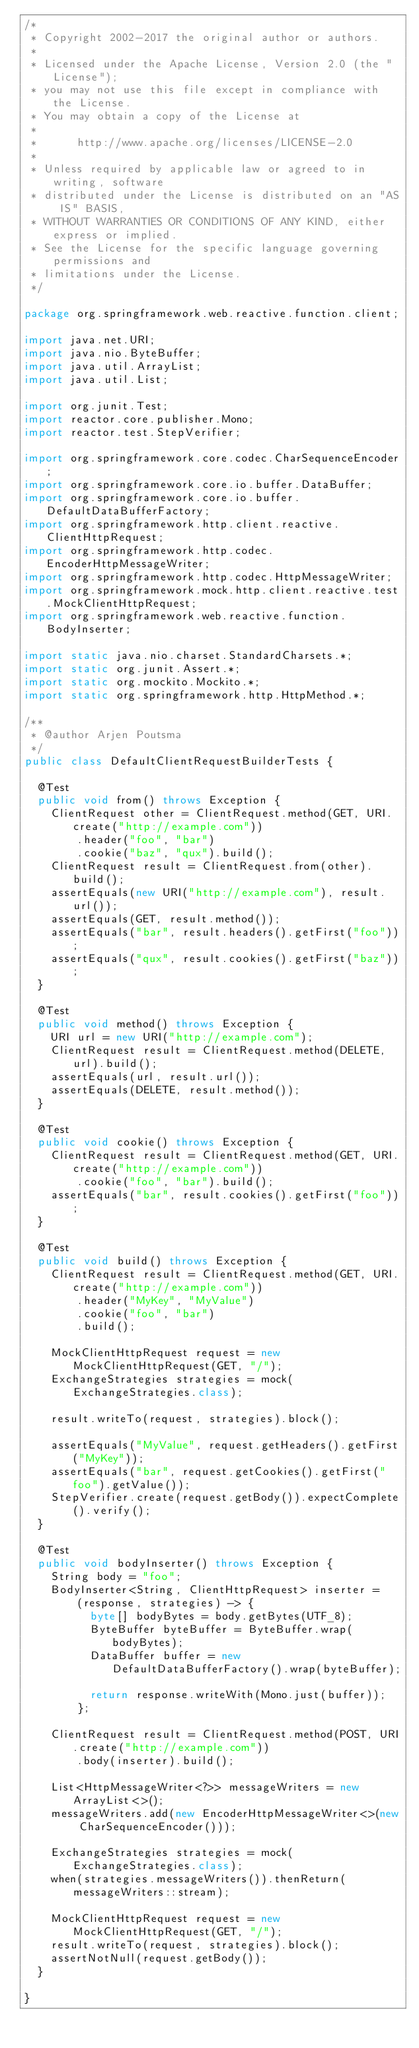<code> <loc_0><loc_0><loc_500><loc_500><_Java_>/*
 * Copyright 2002-2017 the original author or authors.
 *
 * Licensed under the Apache License, Version 2.0 (the "License");
 * you may not use this file except in compliance with the License.
 * You may obtain a copy of the License at
 *
 *      http://www.apache.org/licenses/LICENSE-2.0
 *
 * Unless required by applicable law or agreed to in writing, software
 * distributed under the License is distributed on an "AS IS" BASIS,
 * WITHOUT WARRANTIES OR CONDITIONS OF ANY KIND, either express or implied.
 * See the License for the specific language governing permissions and
 * limitations under the License.
 */

package org.springframework.web.reactive.function.client;

import java.net.URI;
import java.nio.ByteBuffer;
import java.util.ArrayList;
import java.util.List;

import org.junit.Test;
import reactor.core.publisher.Mono;
import reactor.test.StepVerifier;

import org.springframework.core.codec.CharSequenceEncoder;
import org.springframework.core.io.buffer.DataBuffer;
import org.springframework.core.io.buffer.DefaultDataBufferFactory;
import org.springframework.http.client.reactive.ClientHttpRequest;
import org.springframework.http.codec.EncoderHttpMessageWriter;
import org.springframework.http.codec.HttpMessageWriter;
import org.springframework.mock.http.client.reactive.test.MockClientHttpRequest;
import org.springframework.web.reactive.function.BodyInserter;

import static java.nio.charset.StandardCharsets.*;
import static org.junit.Assert.*;
import static org.mockito.Mockito.*;
import static org.springframework.http.HttpMethod.*;

/**
 * @author Arjen Poutsma
 */
public class DefaultClientRequestBuilderTests {

	@Test
	public void from() throws Exception {
		ClientRequest other = ClientRequest.method(GET, URI.create("http://example.com"))
				.header("foo", "bar")
				.cookie("baz", "qux").build();
		ClientRequest result = ClientRequest.from(other).build();
		assertEquals(new URI("http://example.com"), result.url());
		assertEquals(GET, result.method());
		assertEquals("bar", result.headers().getFirst("foo"));
		assertEquals("qux", result.cookies().getFirst("baz"));
	}

	@Test
	public void method() throws Exception {
		URI url = new URI("http://example.com");
		ClientRequest result = ClientRequest.method(DELETE, url).build();
		assertEquals(url, result.url());
		assertEquals(DELETE, result.method());
	}

	@Test
	public void cookie() throws Exception {
		ClientRequest result = ClientRequest.method(GET, URI.create("http://example.com"))
				.cookie("foo", "bar").build();
		assertEquals("bar", result.cookies().getFirst("foo"));
	}

	@Test
	public void build() throws Exception {
		ClientRequest result = ClientRequest.method(GET, URI.create("http://example.com"))
				.header("MyKey", "MyValue")
				.cookie("foo", "bar")
				.build();

		MockClientHttpRequest request = new MockClientHttpRequest(GET, "/");
		ExchangeStrategies strategies = mock(ExchangeStrategies.class);

		result.writeTo(request, strategies).block();

		assertEquals("MyValue", request.getHeaders().getFirst("MyKey"));
		assertEquals("bar", request.getCookies().getFirst("foo").getValue());
		StepVerifier.create(request.getBody()).expectComplete().verify();
	}

	@Test
	public void bodyInserter() throws Exception {
		String body = "foo";
		BodyInserter<String, ClientHttpRequest> inserter =
				(response, strategies) -> {
					byte[] bodyBytes = body.getBytes(UTF_8);
					ByteBuffer byteBuffer = ByteBuffer.wrap(bodyBytes);
					DataBuffer buffer = new DefaultDataBufferFactory().wrap(byteBuffer);

					return response.writeWith(Mono.just(buffer));
				};

		ClientRequest result = ClientRequest.method(POST, URI.create("http://example.com"))
				.body(inserter).build();

		List<HttpMessageWriter<?>> messageWriters = new ArrayList<>();
		messageWriters.add(new EncoderHttpMessageWriter<>(new CharSequenceEncoder()));

		ExchangeStrategies strategies = mock(ExchangeStrategies.class);
		when(strategies.messageWriters()).thenReturn(messageWriters::stream);

		MockClientHttpRequest request = new MockClientHttpRequest(GET, "/");
		result.writeTo(request, strategies).block();
		assertNotNull(request.getBody());
	}

}</code> 